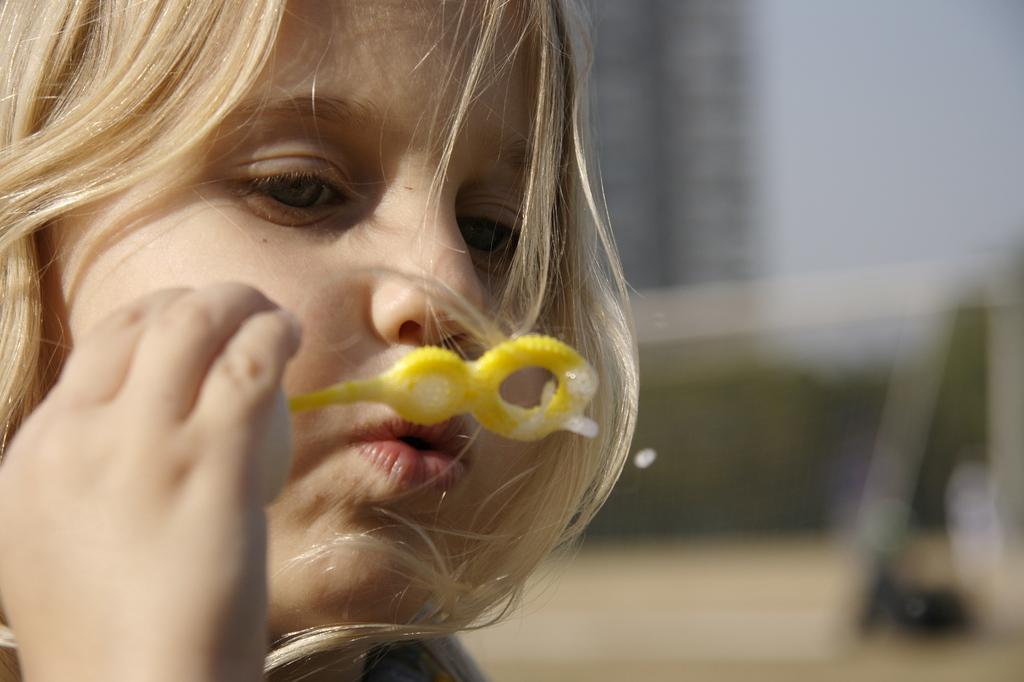Who is the main subject in the image? There is a girl in the image. What is the girl doing in the image? The girl is blowing soap bubbles. Can you describe the girl's hair color? The girl has cream-colored hair. How would you describe the background of the image? The background of the image is blurred. What type of dress is the worm wearing in the image? There is no worm present in the image, and therefore no dress or any other clothing can be observed. 